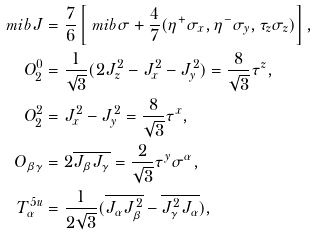Convert formula to latex. <formula><loc_0><loc_0><loc_500><loc_500>\ m i b { J } & = \frac { 7 } { 6 } \left [ \ m i b { \sigma } + \frac { 4 } { 7 } ( \eta ^ { + } \sigma _ { x } , \eta ^ { - } \sigma _ { y } , \tau _ { z } \sigma _ { z } ) \right ] , \\ O ^ { 0 } _ { 2 } & = \frac { 1 } { \sqrt { 3 } } ( 2 J ^ { 2 } _ { z } - J ^ { 2 } _ { x } - J ^ { 2 } _ { y } ) = \frac { 8 } { \sqrt { 3 } } \tau ^ { z } , \\ O ^ { 2 } _ { 2 } & = J ^ { 2 } _ { x } - J ^ { 2 } _ { y } = \frac { 8 } { \sqrt { 3 } } \tau ^ { x } , \\ O _ { \beta \gamma } & = 2 \overline { J _ { \beta } J _ { \gamma } } = \frac { 2 } { \sqrt { 3 } } \tau ^ { y } \sigma ^ { \alpha } , \\ T ^ { 5 u } _ { \alpha } & = \frac { 1 } { 2 \sqrt { 3 } } ( \overline { J _ { \alpha } J ^ { 2 } _ { \beta } } - \overline { J ^ { 2 } _ { \gamma } J _ { \alpha } } ) ,</formula> 